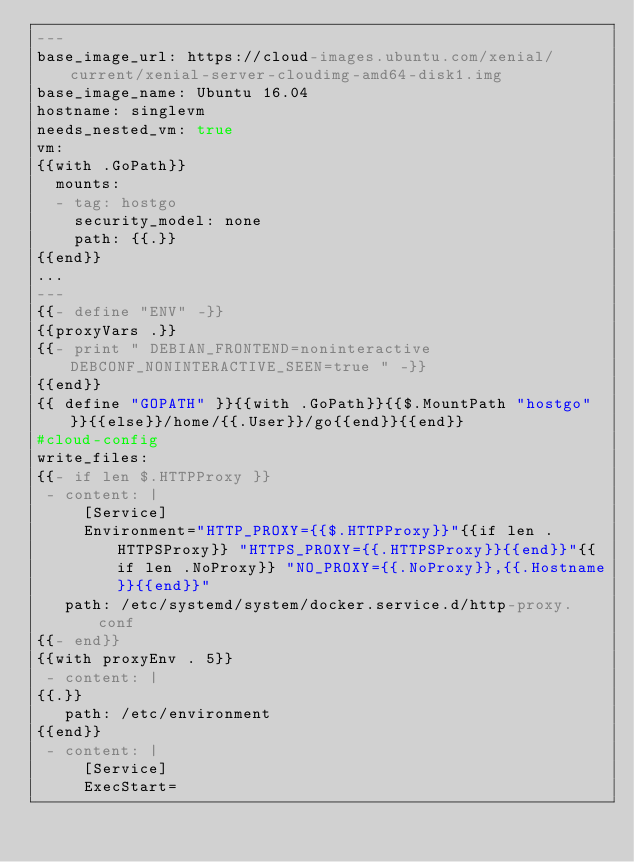<code> <loc_0><loc_0><loc_500><loc_500><_YAML_>---
base_image_url: https://cloud-images.ubuntu.com/xenial/current/xenial-server-cloudimg-amd64-disk1.img
base_image_name: Ubuntu 16.04
hostname: singlevm
needs_nested_vm: true
vm:
{{with .GoPath}}
  mounts:
  - tag: hostgo
    security_model: none
    path: {{.}}
{{end}}
...
---
{{- define "ENV" -}}
{{proxyVars .}}
{{- print " DEBIAN_FRONTEND=noninteractive DEBCONF_NONINTERACTIVE_SEEN=true " -}}
{{end}}
{{ define "GOPATH" }}{{with .GoPath}}{{$.MountPath "hostgo"}}{{else}}/home/{{.User}}/go{{end}}{{end}}
#cloud-config
write_files:
{{- if len $.HTTPProxy }}
 - content: |
     [Service]
     Environment="HTTP_PROXY={{$.HTTPProxy}}"{{if len .HTTPSProxy}} "HTTPS_PROXY={{.HTTPSProxy}}{{end}}"{{if len .NoProxy}} "NO_PROXY={{.NoProxy}},{{.Hostname}}{{end}}"
   path: /etc/systemd/system/docker.service.d/http-proxy.conf
{{- end}}
{{with proxyEnv . 5}}
 - content: |
{{.}}
   path: /etc/environment
{{end}}
 - content: |
     [Service]
     ExecStart=</code> 